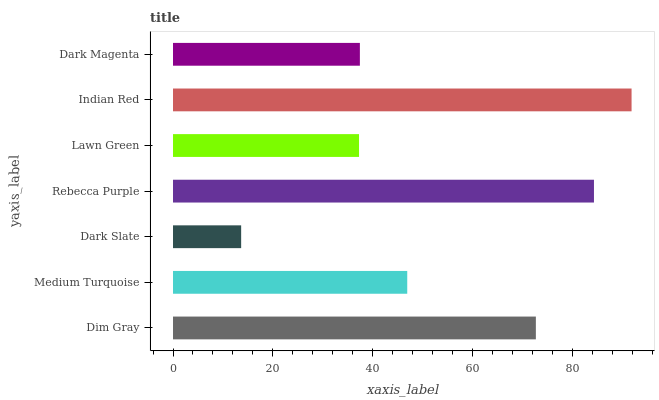Is Dark Slate the minimum?
Answer yes or no. Yes. Is Indian Red the maximum?
Answer yes or no. Yes. Is Medium Turquoise the minimum?
Answer yes or no. No. Is Medium Turquoise the maximum?
Answer yes or no. No. Is Dim Gray greater than Medium Turquoise?
Answer yes or no. Yes. Is Medium Turquoise less than Dim Gray?
Answer yes or no. Yes. Is Medium Turquoise greater than Dim Gray?
Answer yes or no. No. Is Dim Gray less than Medium Turquoise?
Answer yes or no. No. Is Medium Turquoise the high median?
Answer yes or no. Yes. Is Medium Turquoise the low median?
Answer yes or no. Yes. Is Rebecca Purple the high median?
Answer yes or no. No. Is Dark Slate the low median?
Answer yes or no. No. 